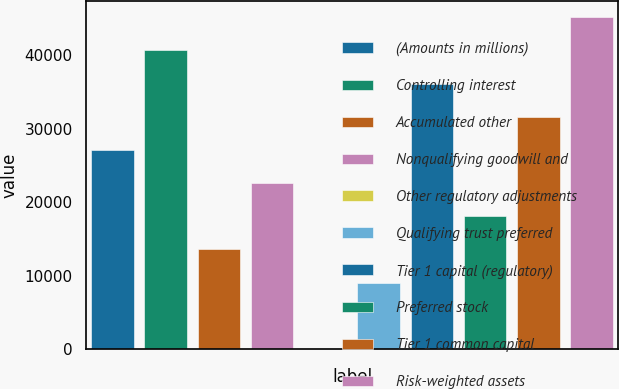Convert chart to OTSL. <chart><loc_0><loc_0><loc_500><loc_500><bar_chart><fcel>(Amounts in millions)<fcel>Controlling interest<fcel>Accumulated other<fcel>Nonqualifying goodwill and<fcel>Other regulatory adjustments<fcel>Qualifying trust preferred<fcel>Tier 1 capital (regulatory)<fcel>Preferred stock<fcel>Tier 1 common capital<fcel>Risk-weighted assets<nl><fcel>27090<fcel>40632<fcel>13548<fcel>22576<fcel>6<fcel>9034<fcel>36118<fcel>18062<fcel>31604<fcel>45146<nl></chart> 